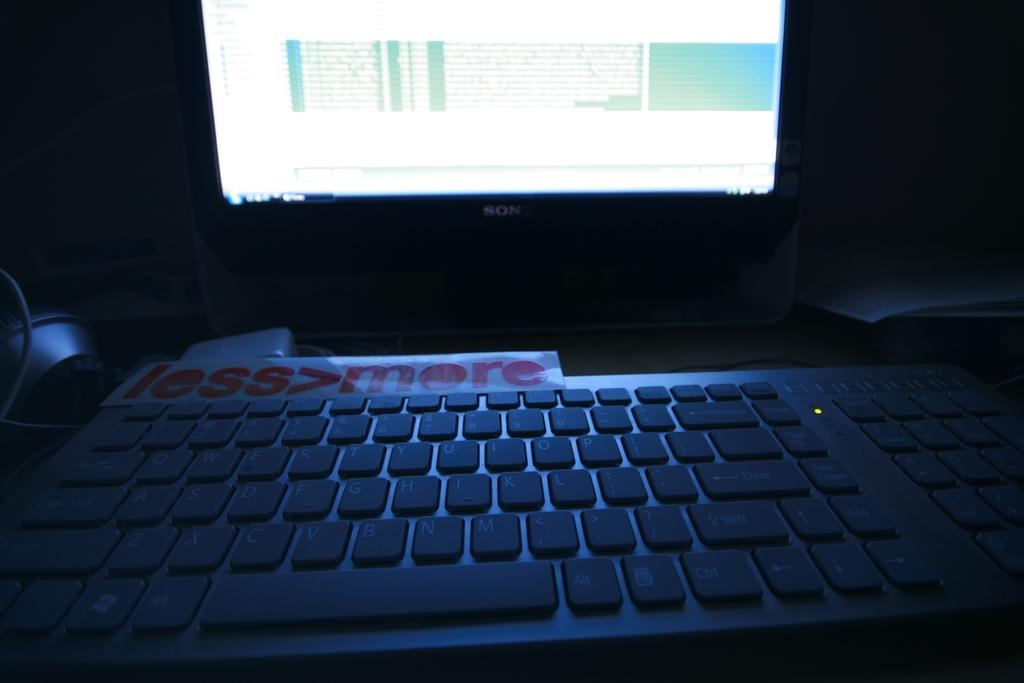What electronic device is visible in the image? There is a monitor in the image. What is used for input with the monitor? There is a keyboard in the image. What type of physical objects are present on the platform with the monitor and keyboard? There are papers in the image. Where are the monitor, keyboard, and papers located? The monitor, keyboard, and papers are on a platform. Can you see any mountains in the image? There are no mountains present in the image. What type of tooth is being used to type on the keyboard in the image? There is no tooth being used to type on the keyboard in the image; a person would typically use their fingers. 